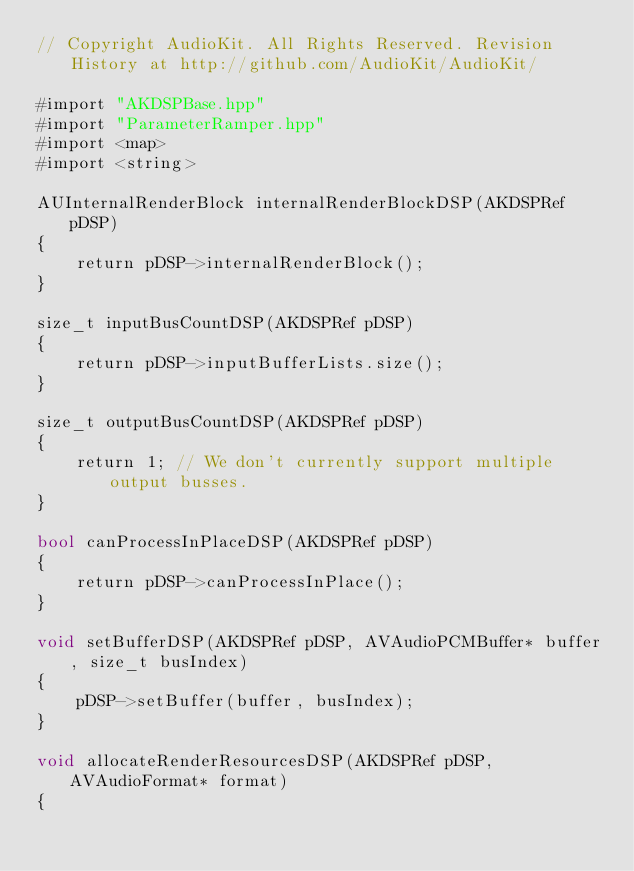<code> <loc_0><loc_0><loc_500><loc_500><_ObjectiveC_>// Copyright AudioKit. All Rights Reserved. Revision History at http://github.com/AudioKit/AudioKit/

#import "AKDSPBase.hpp"
#import "ParameterRamper.hpp"
#import <map>
#import <string>

AUInternalRenderBlock internalRenderBlockDSP(AKDSPRef pDSP)
{
    return pDSP->internalRenderBlock();
}

size_t inputBusCountDSP(AKDSPRef pDSP)
{
    return pDSP->inputBufferLists.size();
}

size_t outputBusCountDSP(AKDSPRef pDSP)
{
    return 1; // We don't currently support multiple output busses.
}

bool canProcessInPlaceDSP(AKDSPRef pDSP)
{
    return pDSP->canProcessInPlace();
}

void setBufferDSP(AKDSPRef pDSP, AVAudioPCMBuffer* buffer, size_t busIndex)
{
    pDSP->setBuffer(buffer, busIndex);
}

void allocateRenderResourcesDSP(AKDSPRef pDSP, AVAudioFormat* format)
{</code> 